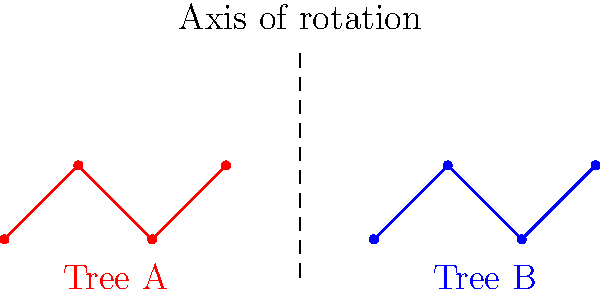In developing your genealogical research app, you need to implement a feature that compares family trees. Given two family tree structures A and B as shown, how many 90-degree rotations clockwise around the central axis are required for Tree B to align with Tree A, assuming they represent the same family structure? To solve this problem, we need to follow these steps:

1. Observe the initial orientation of both trees:
   - Tree A has a down-up-down pattern from left to right
   - Tree B has a down-up-down pattern from left to right

2. Understand that a 90-degree clockwise rotation will change the orientation:
   - 1st rotation (90°): left-right becomes top-bottom
   - 2nd rotation (180°): top-bottom becomes right-left
   - 3rd rotation (270°): right-left becomes bottom-top
   - 4th rotation (360° or 0°): back to original orientation

3. Analyze the rotations:
   - After 1 rotation (90°): Tree B will have an up-down-up pattern from top to bottom
   - After 2 rotations (180°): Tree B will have an up-down-up pattern from right to left
   - After 3 rotations (270°): Tree B will have a down-up-down pattern from bottom to top
   - After 4 rotations (360°): Tree B will be back to its original orientation

4. Compare with Tree A:
   - Tree A has a down-up-down pattern from left to right
   - This matches the orientation of Tree B after 3 rotations

Therefore, 3 clockwise rotations of 90° each (totaling 270°) are required for Tree B to align with Tree A.
Answer: 3 rotations 